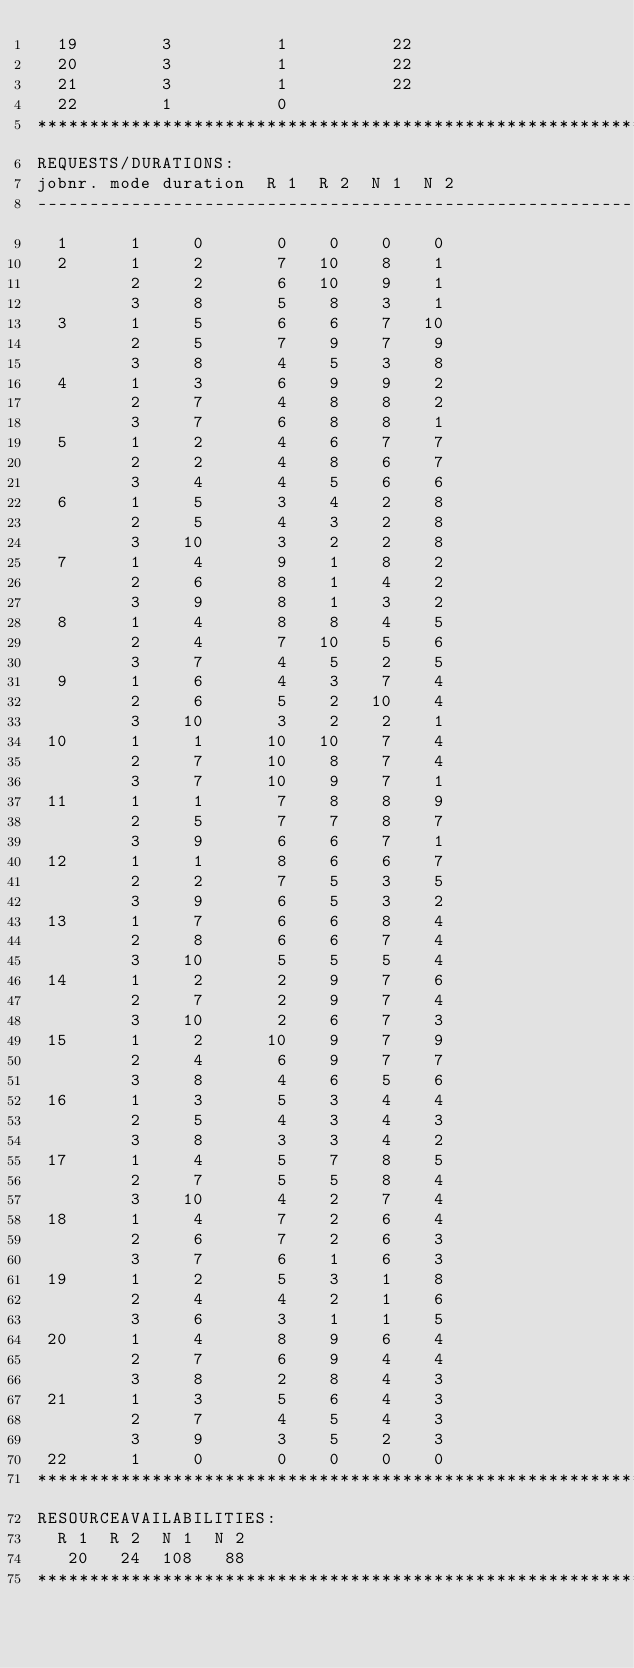Convert code to text. <code><loc_0><loc_0><loc_500><loc_500><_ObjectiveC_>  19        3          1          22
  20        3          1          22
  21        3          1          22
  22        1          0        
************************************************************************
REQUESTS/DURATIONS:
jobnr. mode duration  R 1  R 2  N 1  N 2
------------------------------------------------------------------------
  1      1     0       0    0    0    0
  2      1     2       7   10    8    1
         2     2       6   10    9    1
         3     8       5    8    3    1
  3      1     5       6    6    7   10
         2     5       7    9    7    9
         3     8       4    5    3    8
  4      1     3       6    9    9    2
         2     7       4    8    8    2
         3     7       6    8    8    1
  5      1     2       4    6    7    7
         2     2       4    8    6    7
         3     4       4    5    6    6
  6      1     5       3    4    2    8
         2     5       4    3    2    8
         3    10       3    2    2    8
  7      1     4       9    1    8    2
         2     6       8    1    4    2
         3     9       8    1    3    2
  8      1     4       8    8    4    5
         2     4       7   10    5    6
         3     7       4    5    2    5
  9      1     6       4    3    7    4
         2     6       5    2   10    4
         3    10       3    2    2    1
 10      1     1      10   10    7    4
         2     7      10    8    7    4
         3     7      10    9    7    1
 11      1     1       7    8    8    9
         2     5       7    7    8    7
         3     9       6    6    7    1
 12      1     1       8    6    6    7
         2     2       7    5    3    5
         3     9       6    5    3    2
 13      1     7       6    6    8    4
         2     8       6    6    7    4
         3    10       5    5    5    4
 14      1     2       2    9    7    6
         2     7       2    9    7    4
         3    10       2    6    7    3
 15      1     2      10    9    7    9
         2     4       6    9    7    7
         3     8       4    6    5    6
 16      1     3       5    3    4    4
         2     5       4    3    4    3
         3     8       3    3    4    2
 17      1     4       5    7    8    5
         2     7       5    5    8    4
         3    10       4    2    7    4
 18      1     4       7    2    6    4
         2     6       7    2    6    3
         3     7       6    1    6    3
 19      1     2       5    3    1    8
         2     4       4    2    1    6
         3     6       3    1    1    5
 20      1     4       8    9    6    4
         2     7       6    9    4    4
         3     8       2    8    4    3
 21      1     3       5    6    4    3
         2     7       4    5    4    3
         3     9       3    5    2    3
 22      1     0       0    0    0    0
************************************************************************
RESOURCEAVAILABILITIES:
  R 1  R 2  N 1  N 2
   20   24  108   88
************************************************************************
</code> 